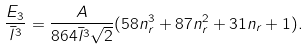Convert formula to latex. <formula><loc_0><loc_0><loc_500><loc_500>\frac { E _ { 3 } } { \bar { l } ^ { 3 } } = \frac { A } { 8 6 4 \bar { l } ^ { 3 } \sqrt { 2 } } ( 5 8 n _ { r } ^ { 3 } + 8 7 n _ { r } ^ { 2 } + 3 1 n _ { r } + 1 ) .</formula> 